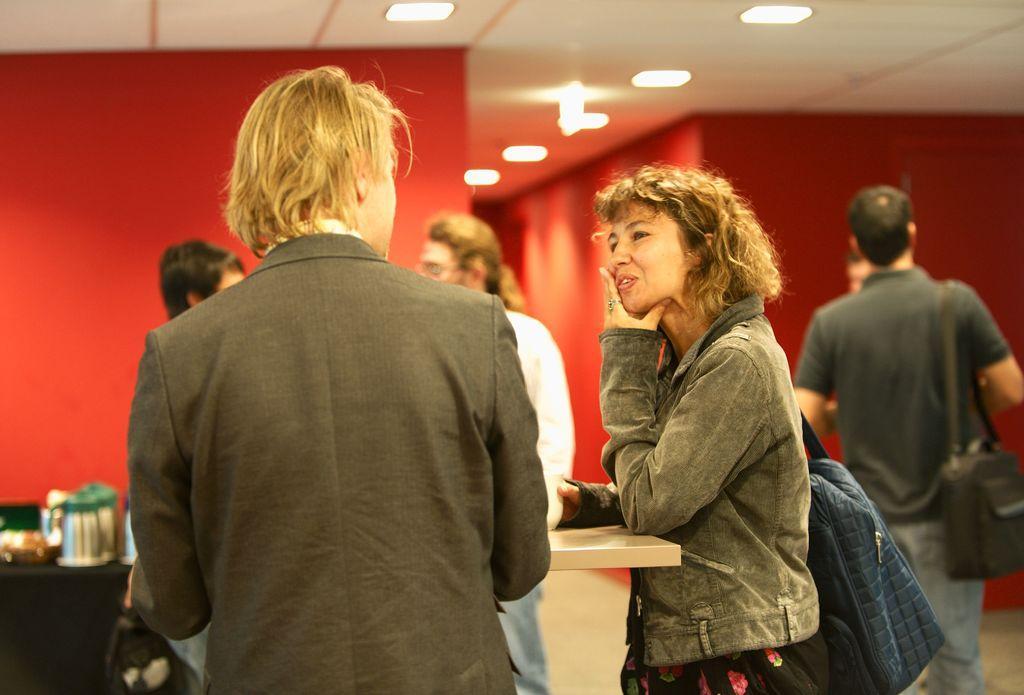Please provide a concise description of this image. In this image we can see the people standing on the floor and we can see a table, on the table there are jars, and few objects. In the background, we can see the wall and at the top we can see the ceiling with lights. 